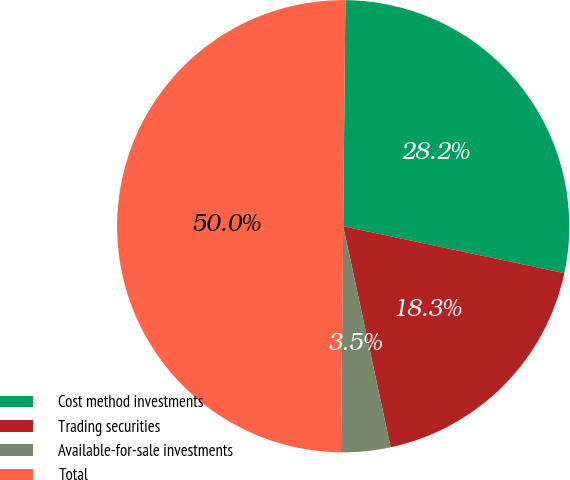<chart> <loc_0><loc_0><loc_500><loc_500><pie_chart><fcel>Cost method investments<fcel>Trading securities<fcel>Available-for-sale investments<fcel>Total<nl><fcel>28.17%<fcel>18.31%<fcel>3.52%<fcel>50.0%<nl></chart> 